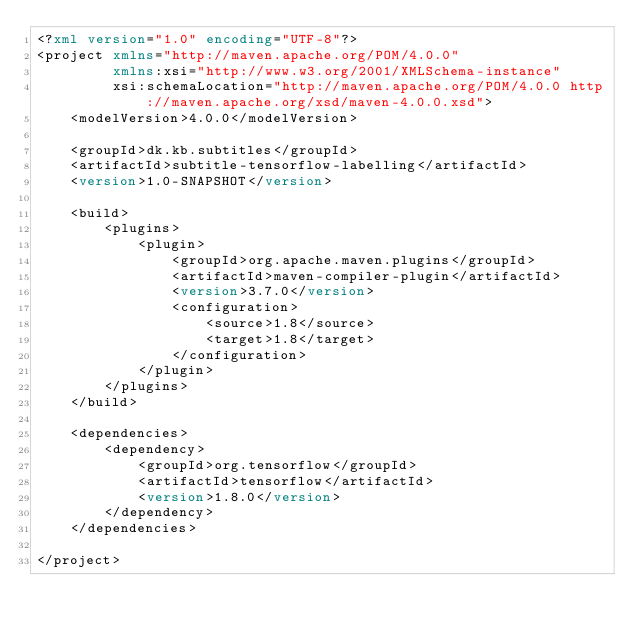<code> <loc_0><loc_0><loc_500><loc_500><_XML_><?xml version="1.0" encoding="UTF-8"?>
<project xmlns="http://maven.apache.org/POM/4.0.0"
         xmlns:xsi="http://www.w3.org/2001/XMLSchema-instance"
         xsi:schemaLocation="http://maven.apache.org/POM/4.0.0 http://maven.apache.org/xsd/maven-4.0.0.xsd">
    <modelVersion>4.0.0</modelVersion>

    <groupId>dk.kb.subtitles</groupId>
    <artifactId>subtitle-tensorflow-labelling</artifactId>
    <version>1.0-SNAPSHOT</version>

    <build>
        <plugins>
            <plugin>
                <groupId>org.apache.maven.plugins</groupId>
                <artifactId>maven-compiler-plugin</artifactId>
                <version>3.7.0</version>
                <configuration>
                    <source>1.8</source>
                    <target>1.8</target>
                </configuration>
            </plugin>
        </plugins>
    </build>

    <dependencies>
        <dependency>
            <groupId>org.tensorflow</groupId>
            <artifactId>tensorflow</artifactId>
            <version>1.8.0</version>
        </dependency>
    </dependencies>

</project>
</code> 